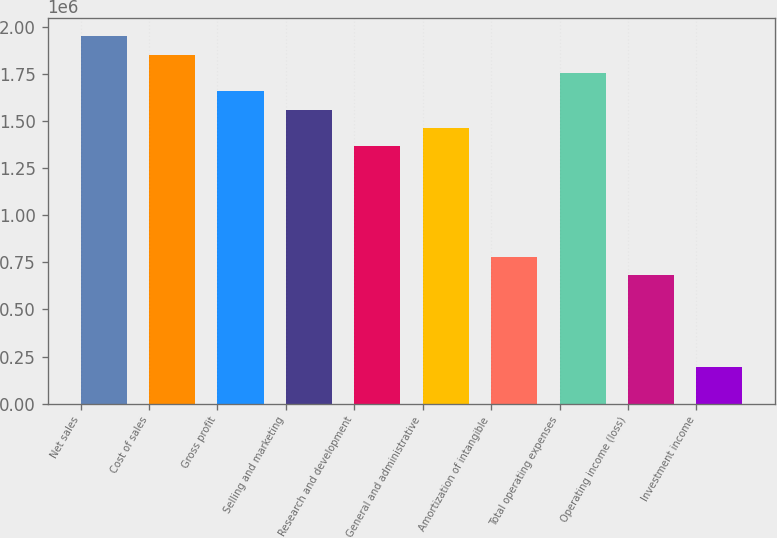Convert chart to OTSL. <chart><loc_0><loc_0><loc_500><loc_500><bar_chart><fcel>Net sales<fcel>Cost of sales<fcel>Gross profit<fcel>Selling and marketing<fcel>Research and development<fcel>General and administrative<fcel>Amortization of intangible<fcel>Total operating expenses<fcel>Operating income (loss)<fcel>Investment income<nl><fcel>1.9534e+06<fcel>1.85573e+06<fcel>1.66039e+06<fcel>1.56272e+06<fcel>1.36738e+06<fcel>1.46505e+06<fcel>781360<fcel>1.75806e+06<fcel>683690<fcel>195340<nl></chart> 